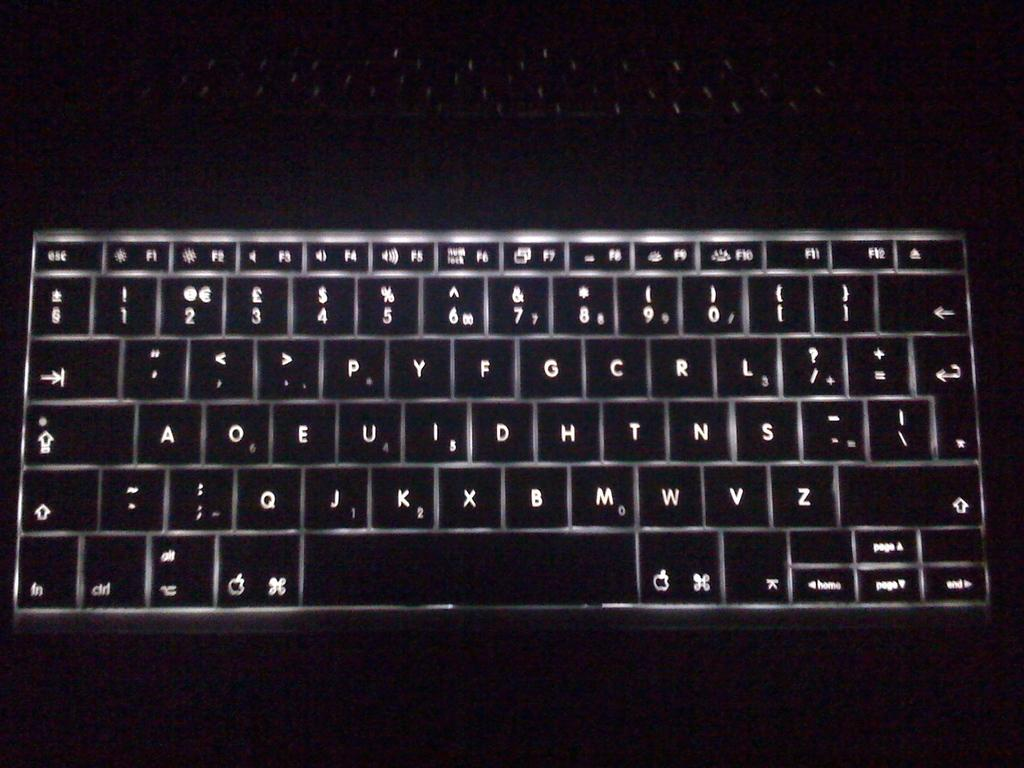What is the main object in the image? There is a keyboard in the image. What feature of the keyboard is mentioned in the facts? The keyboard has lights. What is the title of the journey depicted in the image? There is no journey depicted in the image, as it only features a keyboard with lights. 